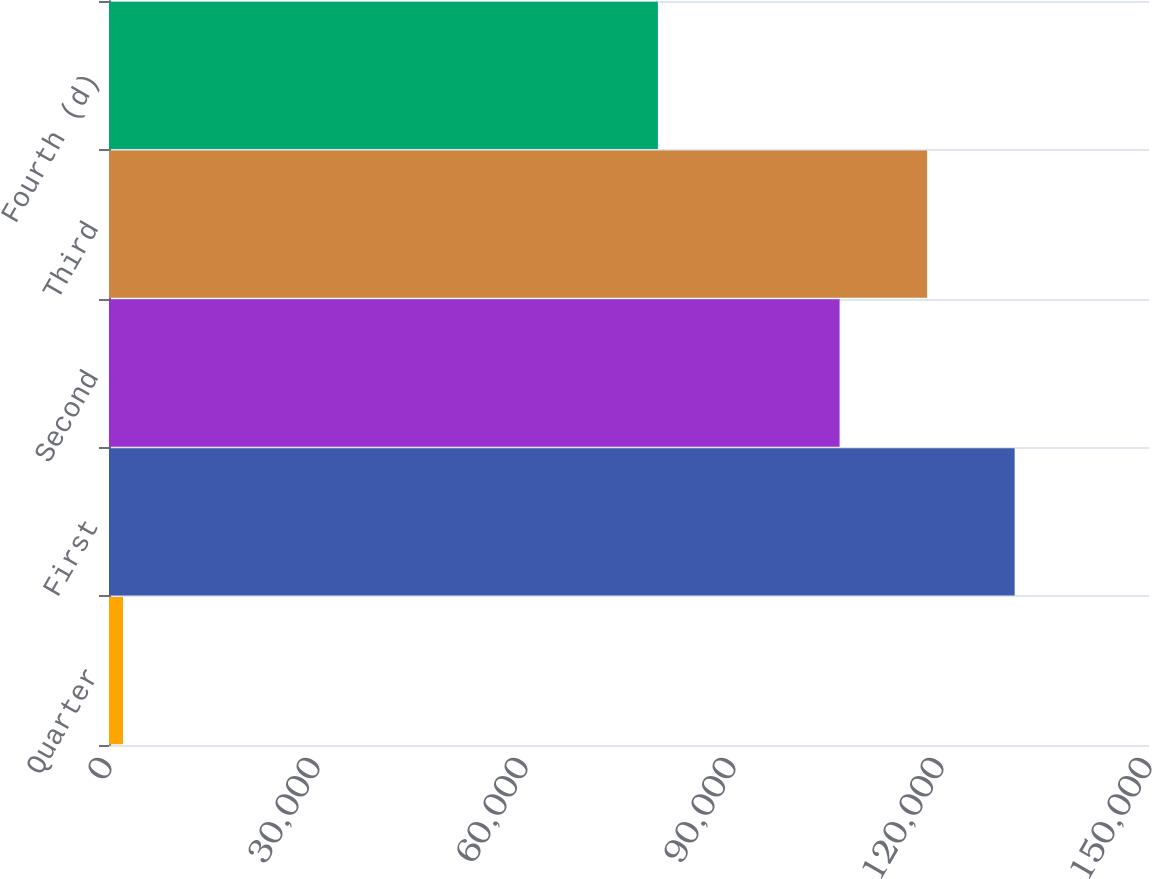Convert chart to OTSL. <chart><loc_0><loc_0><loc_500><loc_500><bar_chart><fcel>Quarter<fcel>First<fcel>Second<fcel>Third<fcel>Fourth (d)<nl><fcel>2015<fcel>130623<fcel>105374<fcel>117998<fcel>79168<nl></chart> 